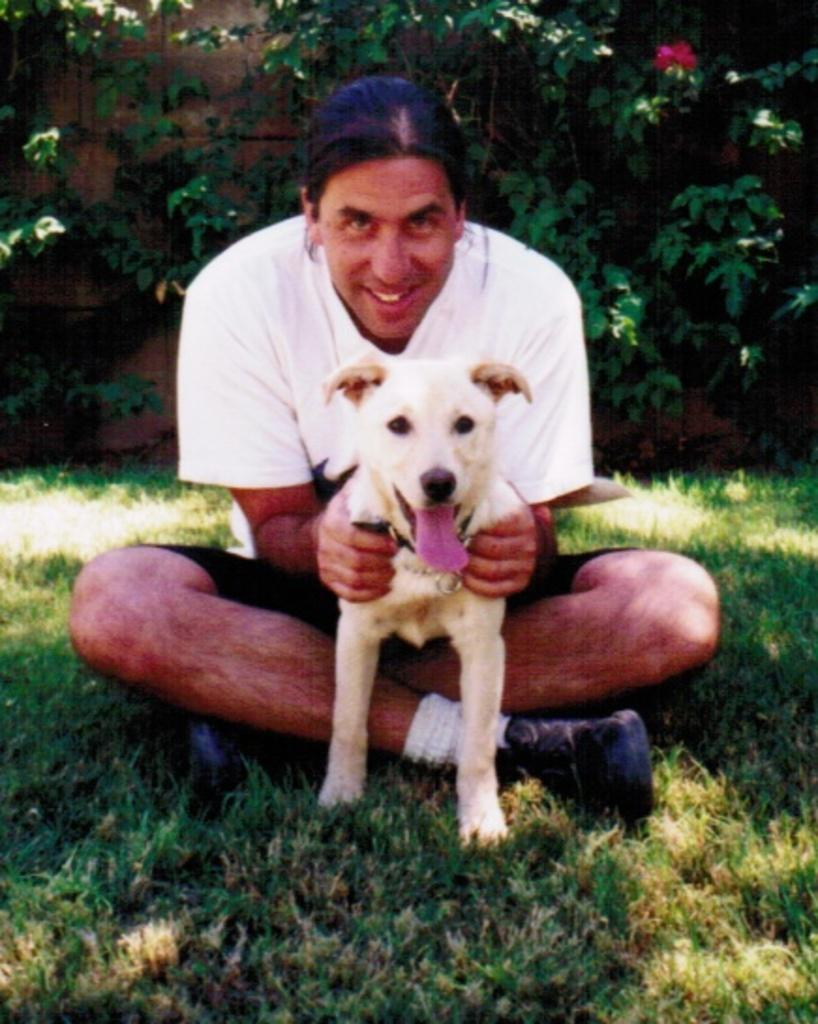What is the person in the image doing? The person is sitting on the grass in the image. What is the person holding in the image? The person is holding a dog in the image. What can be seen in the background of the image? There are trees visible in the background of the image. How far away is the jar from the person in the image? There is no jar present in the image, so it cannot be determined how far away it is from the person. 